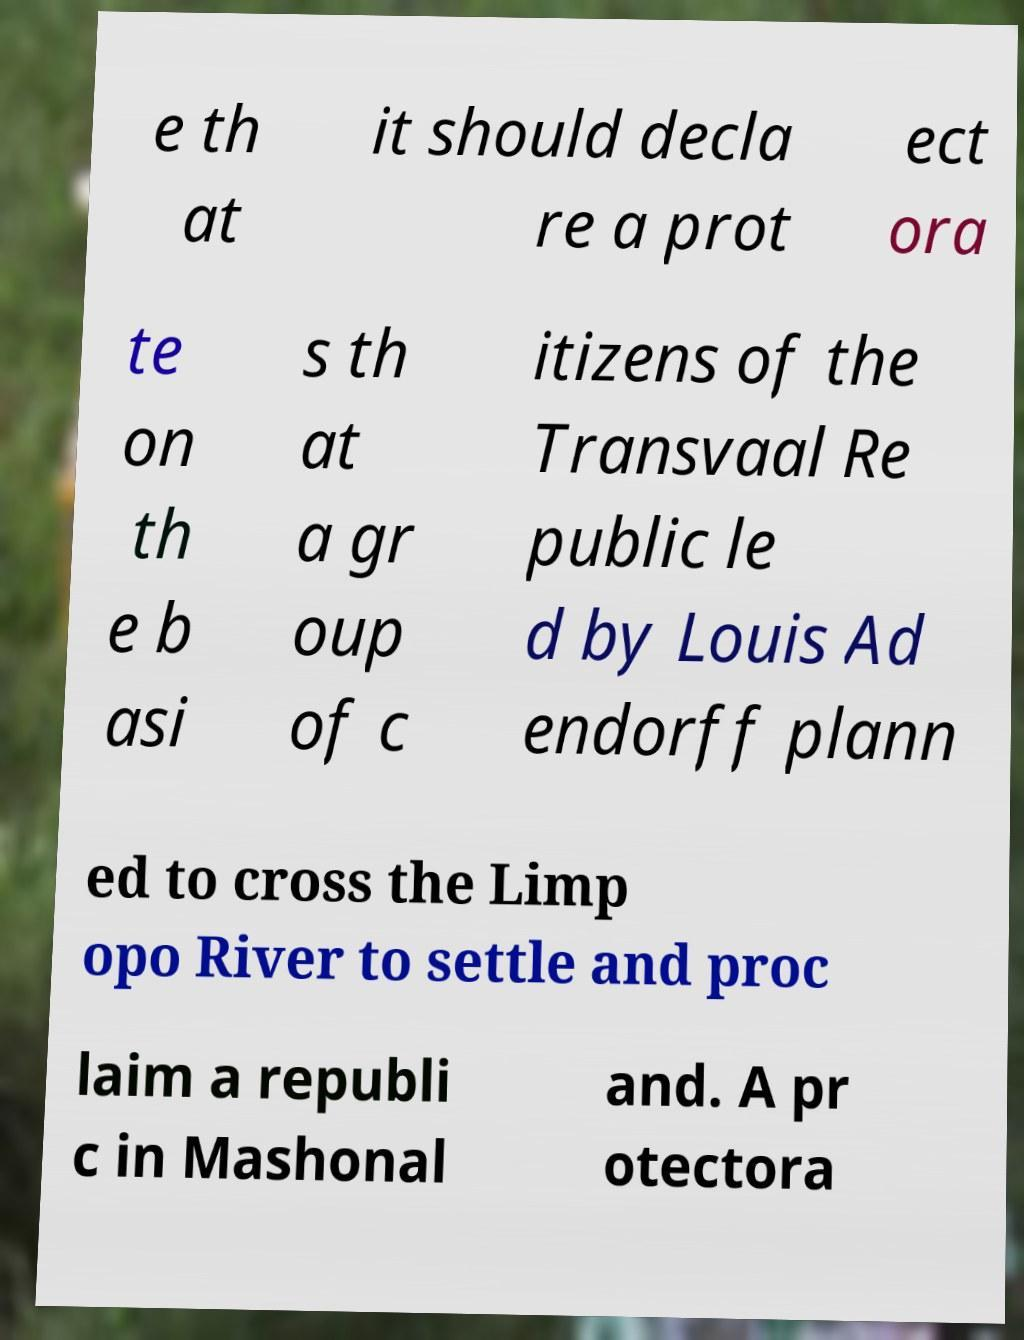Can you accurately transcribe the text from the provided image for me? e th at it should decla re a prot ect ora te on th e b asi s th at a gr oup of c itizens of the Transvaal Re public le d by Louis Ad endorff plann ed to cross the Limp opo River to settle and proc laim a republi c in Mashonal and. A pr otectora 